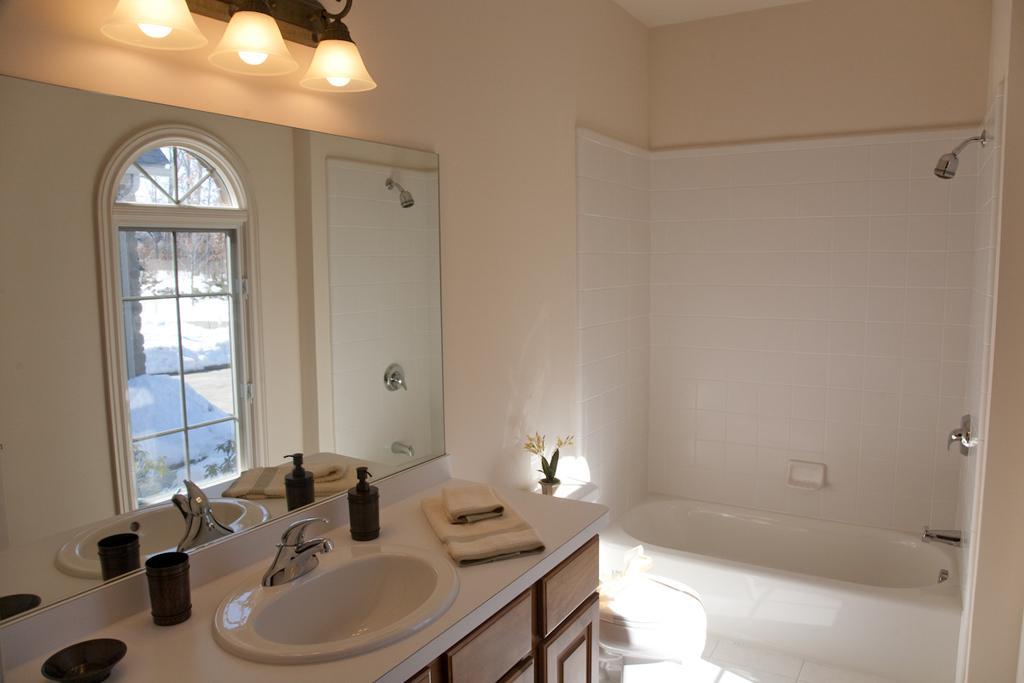Could you give a brief overview of what you see in this image? This picture describes about washroom, in this we can find a bathtub, mirror, shower and few lights, and also we can find a bottle, towels and a tap. 